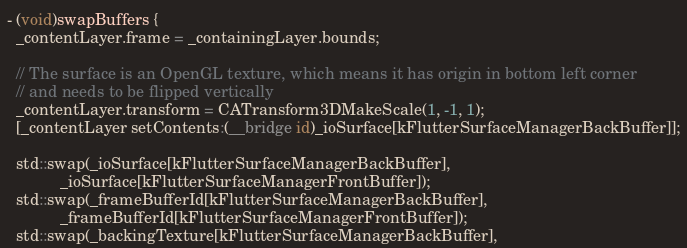<code> <loc_0><loc_0><loc_500><loc_500><_ObjectiveC_>
- (void)swapBuffers {
  _contentLayer.frame = _containingLayer.bounds;

  // The surface is an OpenGL texture, which means it has origin in bottom left corner
  // and needs to be flipped vertically
  _contentLayer.transform = CATransform3DMakeScale(1, -1, 1);
  [_contentLayer setContents:(__bridge id)_ioSurface[kFlutterSurfaceManagerBackBuffer]];

  std::swap(_ioSurface[kFlutterSurfaceManagerBackBuffer],
            _ioSurface[kFlutterSurfaceManagerFrontBuffer]);
  std::swap(_frameBufferId[kFlutterSurfaceManagerBackBuffer],
            _frameBufferId[kFlutterSurfaceManagerFrontBuffer]);
  std::swap(_backingTexture[kFlutterSurfaceManagerBackBuffer],</code> 